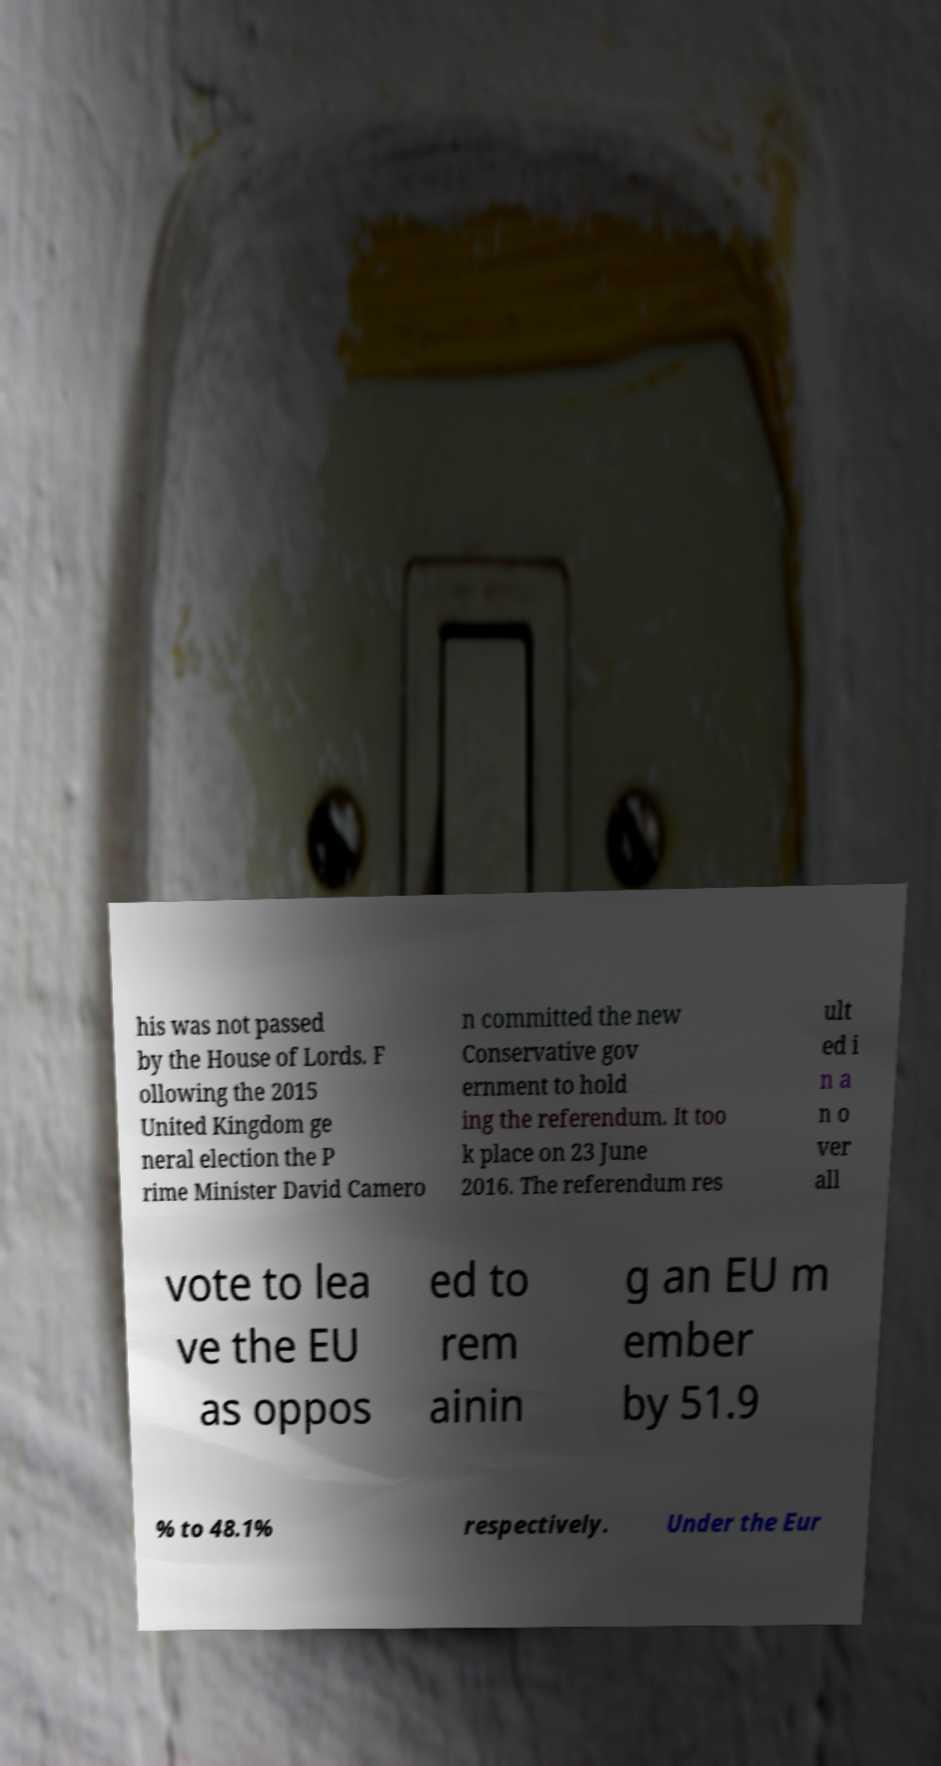For documentation purposes, I need the text within this image transcribed. Could you provide that? his was not passed by the House of Lords. F ollowing the 2015 United Kingdom ge neral election the P rime Minister David Camero n committed the new Conservative gov ernment to hold ing the referendum. It too k place on 23 June 2016. The referendum res ult ed i n a n o ver all vote to lea ve the EU as oppos ed to rem ainin g an EU m ember by 51.9 % to 48.1% respectively. Under the Eur 